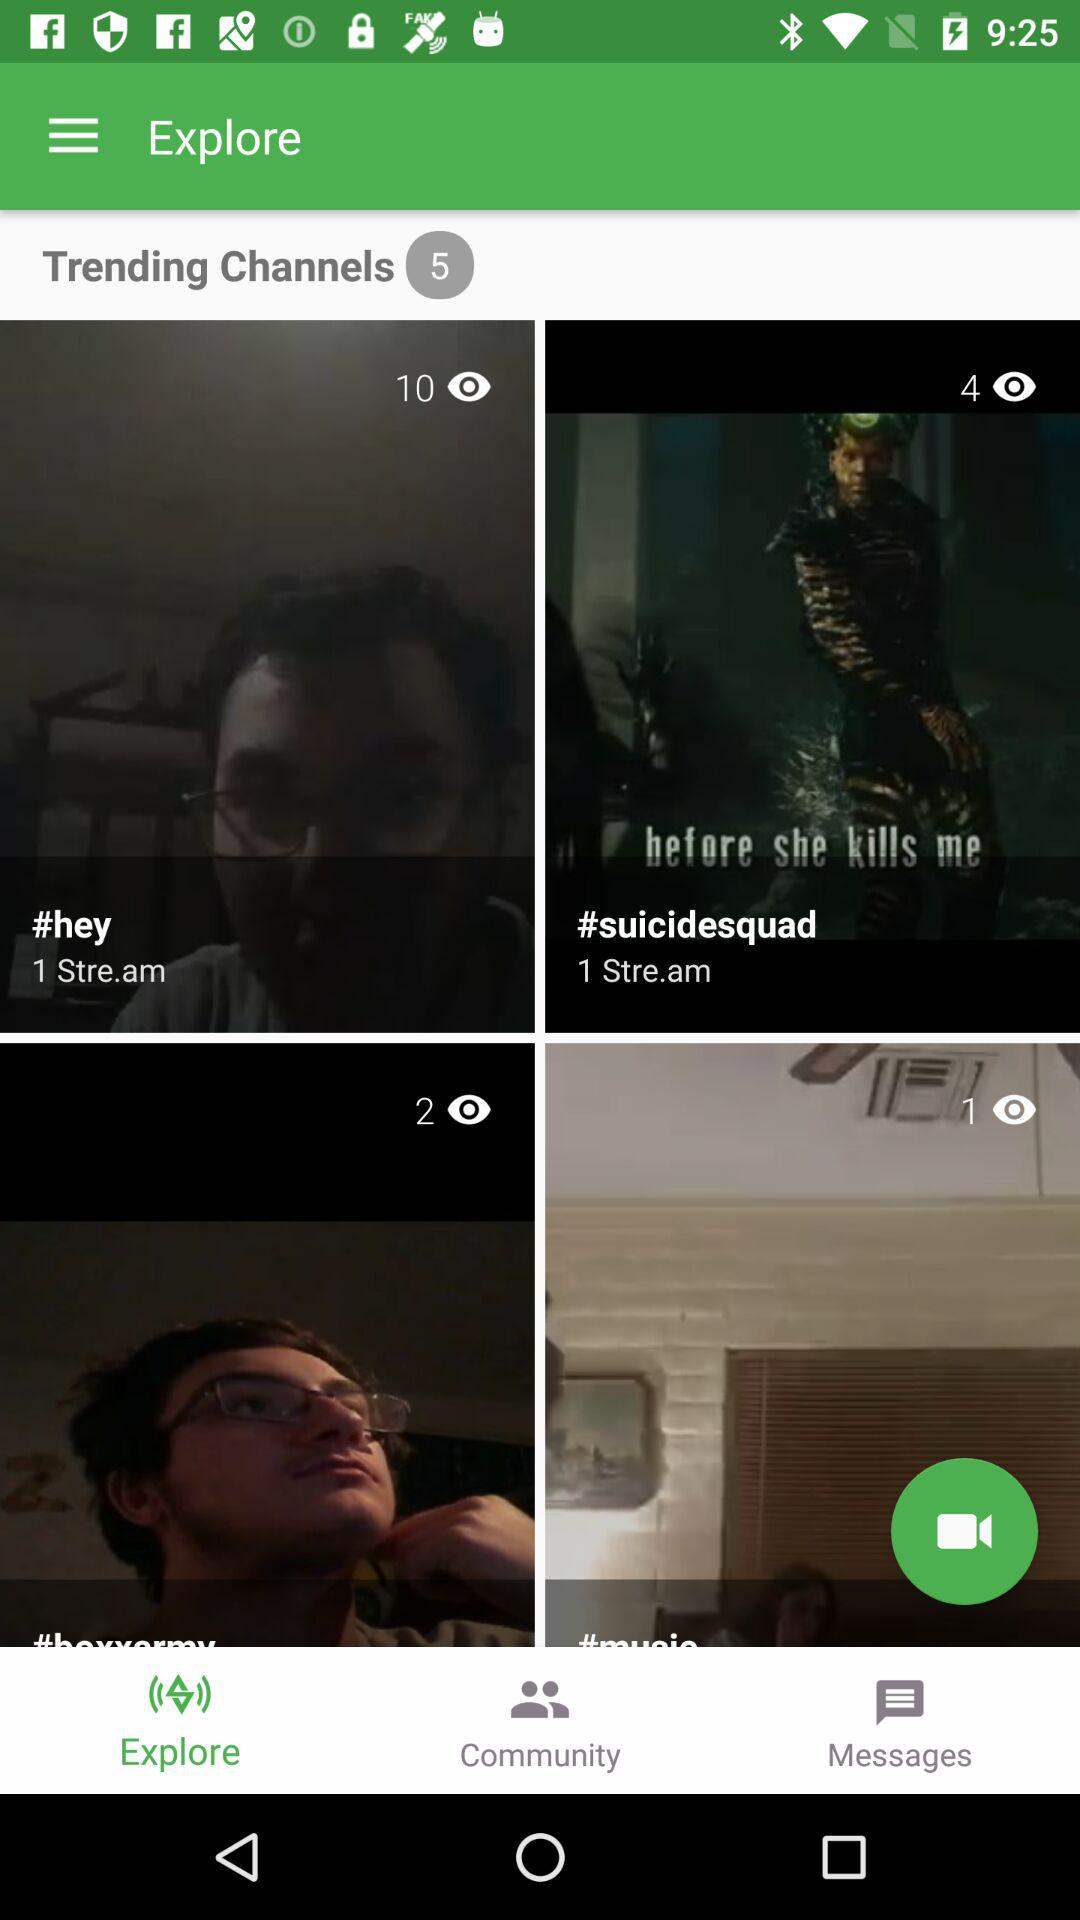How many trending channels are there? There are 5 trending channels. 